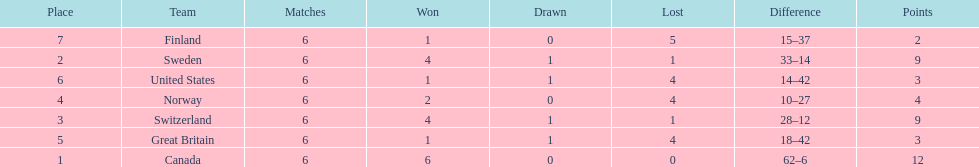How many teams won at least 4 matches? 3. 